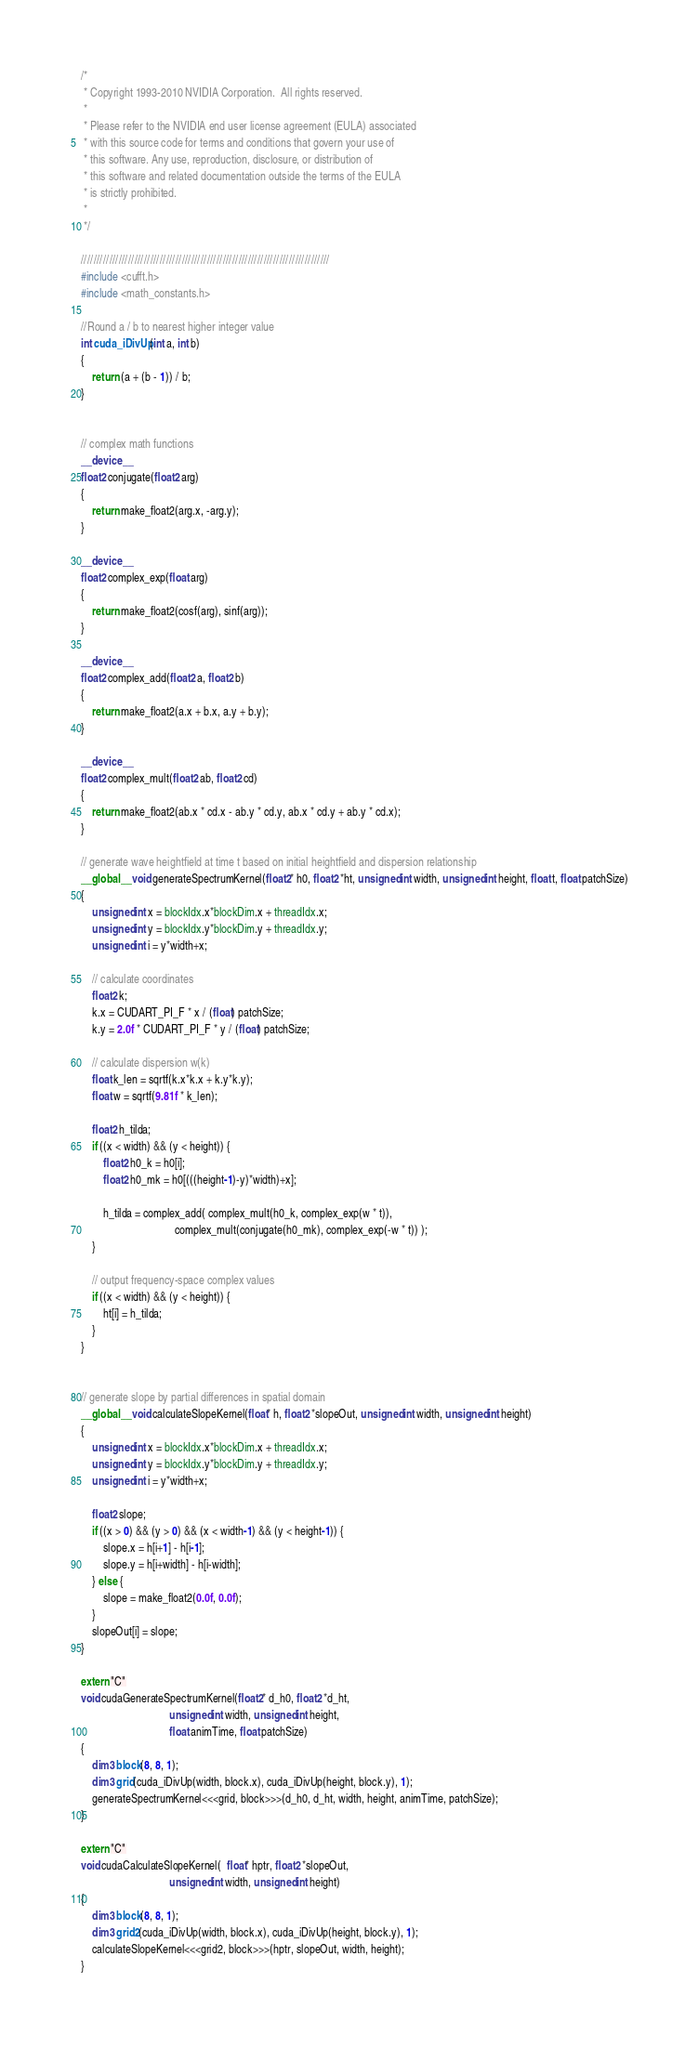<code> <loc_0><loc_0><loc_500><loc_500><_Cuda_>/*
 * Copyright 1993-2010 NVIDIA Corporation.  All rights reserved.
 *
 * Please refer to the NVIDIA end user license agreement (EULA) associated
 * with this source code for terms and conditions that govern your use of
 * this software. Any use, reproduction, disclosure, or distribution of
 * this software and related documentation outside the terms of the EULA
 * is strictly prohibited.
 *
 */

///////////////////////////////////////////////////////////////////////////////
#include <cufft.h>
#include <math_constants.h>

//Round a / b to nearest higher integer value
int cuda_iDivUp(int a, int b)
{
    return (a + (b - 1)) / b;
}


// complex math functions
__device__
float2 conjugate(float2 arg)
{
    return make_float2(arg.x, -arg.y);
}

__device__
float2 complex_exp(float arg)
{
    return make_float2(cosf(arg), sinf(arg));
}

__device__
float2 complex_add(float2 a, float2 b)
{
    return make_float2(a.x + b.x, a.y + b.y);
}

__device__
float2 complex_mult(float2 ab, float2 cd)
{
    return make_float2(ab.x * cd.x - ab.y * cd.y, ab.x * cd.y + ab.y * cd.x);
}

// generate wave heightfield at time t based on initial heightfield and dispersion relationship
__global__ void generateSpectrumKernel(float2* h0, float2 *ht, unsigned int width, unsigned int height, float t, float patchSize)
{
    unsigned int x = blockIdx.x*blockDim.x + threadIdx.x;
    unsigned int y = blockIdx.y*blockDim.y + threadIdx.y;
    unsigned int i = y*width+x;
    
    // calculate coordinates
    float2 k;
    k.x = CUDART_PI_F * x / (float) patchSize;
    k.y = 2.0f * CUDART_PI_F * y / (float) patchSize;

    // calculate dispersion w(k)
    float k_len = sqrtf(k.x*k.x + k.y*k.y);
    float w = sqrtf(9.81f * k_len);

	float2 h_tilda;
	if ((x < width) && (y < height)) {
		float2 h0_k = h0[i];
		float2 h0_mk = h0[(((height-1)-y)*width)+x];

		h_tilda = complex_add( complex_mult(h0_k, complex_exp(w * t)),
                                  complex_mult(conjugate(h0_mk), complex_exp(-w * t)) );
	}

    // output frequency-space complex values
    if ((x < width) && (y < height)) {
        ht[i] = h_tilda;
    }
}


// generate slope by partial differences in spatial domain
__global__ void calculateSlopeKernel(float* h, float2 *slopeOut, unsigned int width, unsigned int height)
{
    unsigned int x = blockIdx.x*blockDim.x + threadIdx.x;
    unsigned int y = blockIdx.y*blockDim.y + threadIdx.y;
    unsigned int i = y*width+x;

    float2 slope;
    if ((x > 0) && (y > 0) && (x < width-1) && (y < height-1)) {
        slope.x = h[i+1] - h[i-1];
        slope.y = h[i+width] - h[i-width];
    } else {
        slope = make_float2(0.0f, 0.0f);
    }
    slopeOut[i] = slope;
}

extern "C" 
void cudaGenerateSpectrumKernel(float2* d_h0, float2 *d_ht, 
                                unsigned int width, unsigned int height, 
                                float animTime, float patchSize)
{
    dim3 block(8, 8, 1);
    dim3 grid(cuda_iDivUp(width, block.x), cuda_iDivUp(height, block.y), 1);
    generateSpectrumKernel<<<grid, block>>>(d_h0, d_ht, width, height, animTime, patchSize);
}

extern "C"
void cudaCalculateSlopeKernel(  float* hptr, float2 *slopeOut, 
                                unsigned int width, unsigned int height)
{
    dim3 block(8, 8, 1);
    dim3 grid2(cuda_iDivUp(width, block.x), cuda_iDivUp(height, block.y), 1);
    calculateSlopeKernel<<<grid2, block>>>(hptr, slopeOut, width, height);
}
</code> 